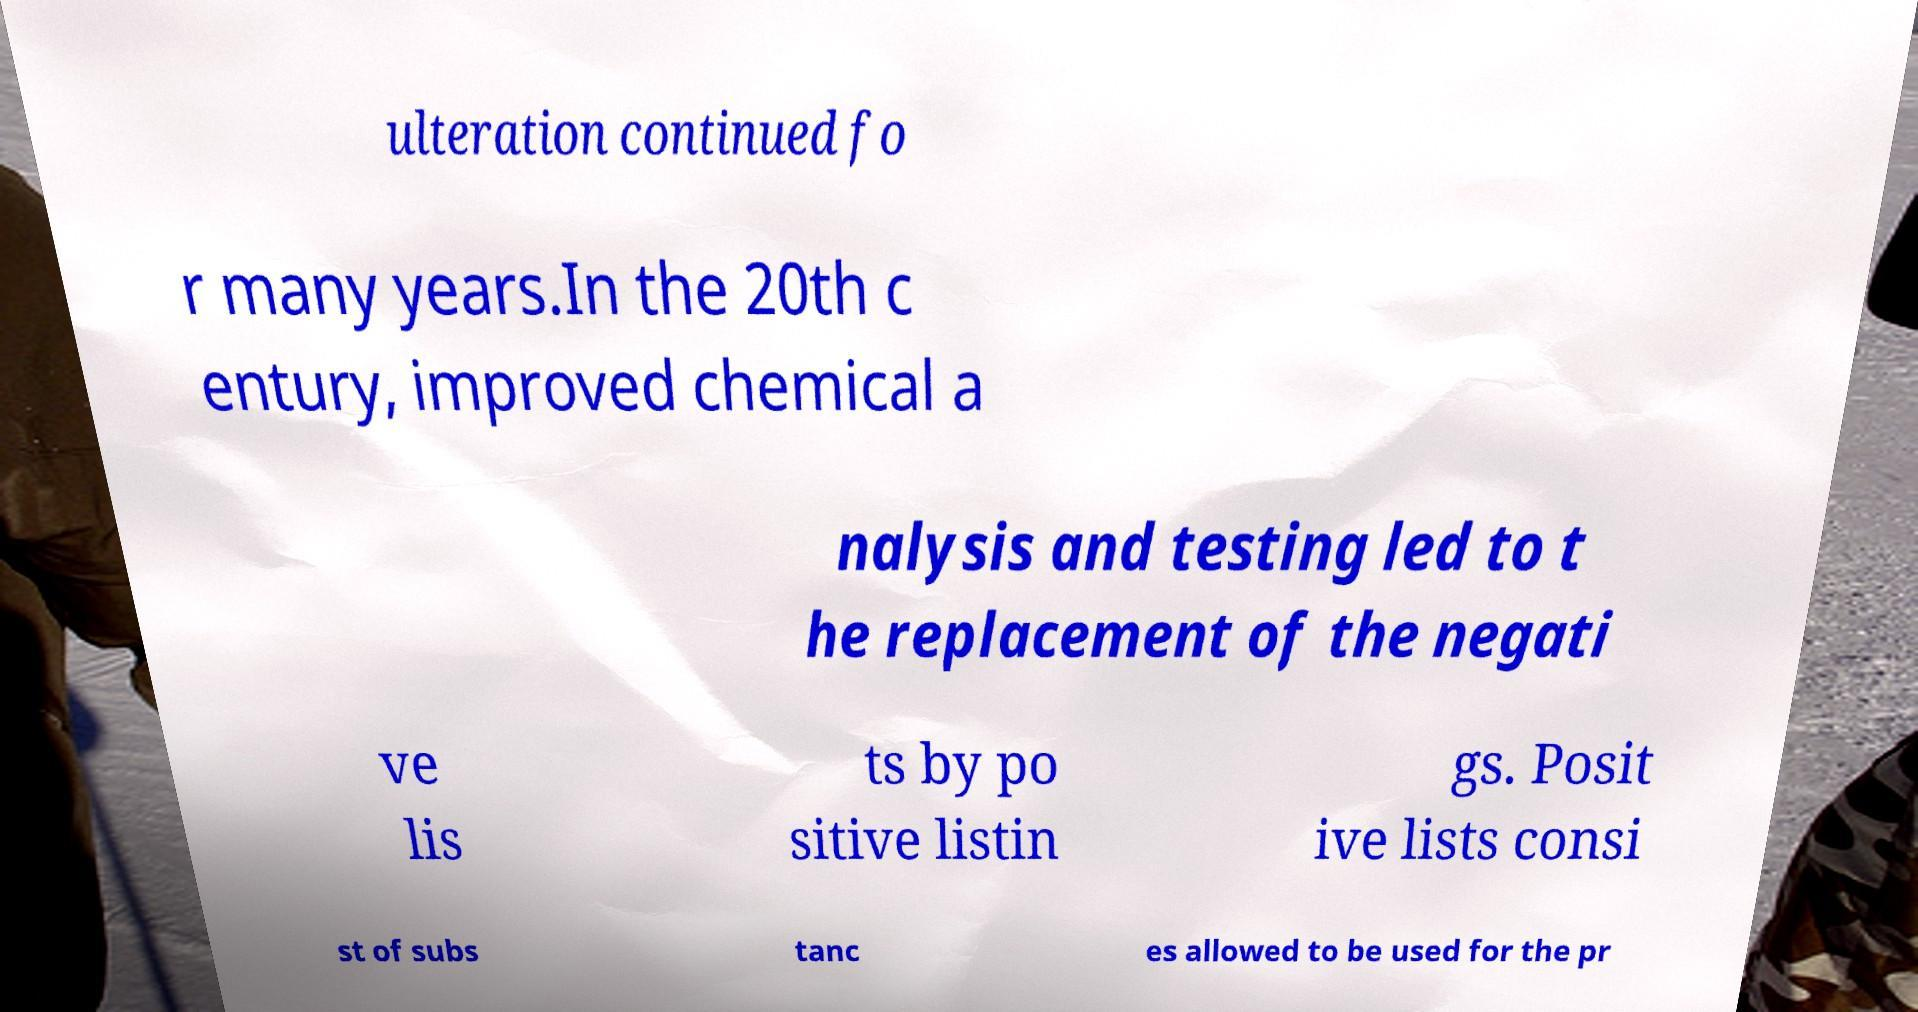Please read and relay the text visible in this image. What does it say? ulteration continued fo r many years.In the 20th c entury, improved chemical a nalysis and testing led to t he replacement of the negati ve lis ts by po sitive listin gs. Posit ive lists consi st of subs tanc es allowed to be used for the pr 